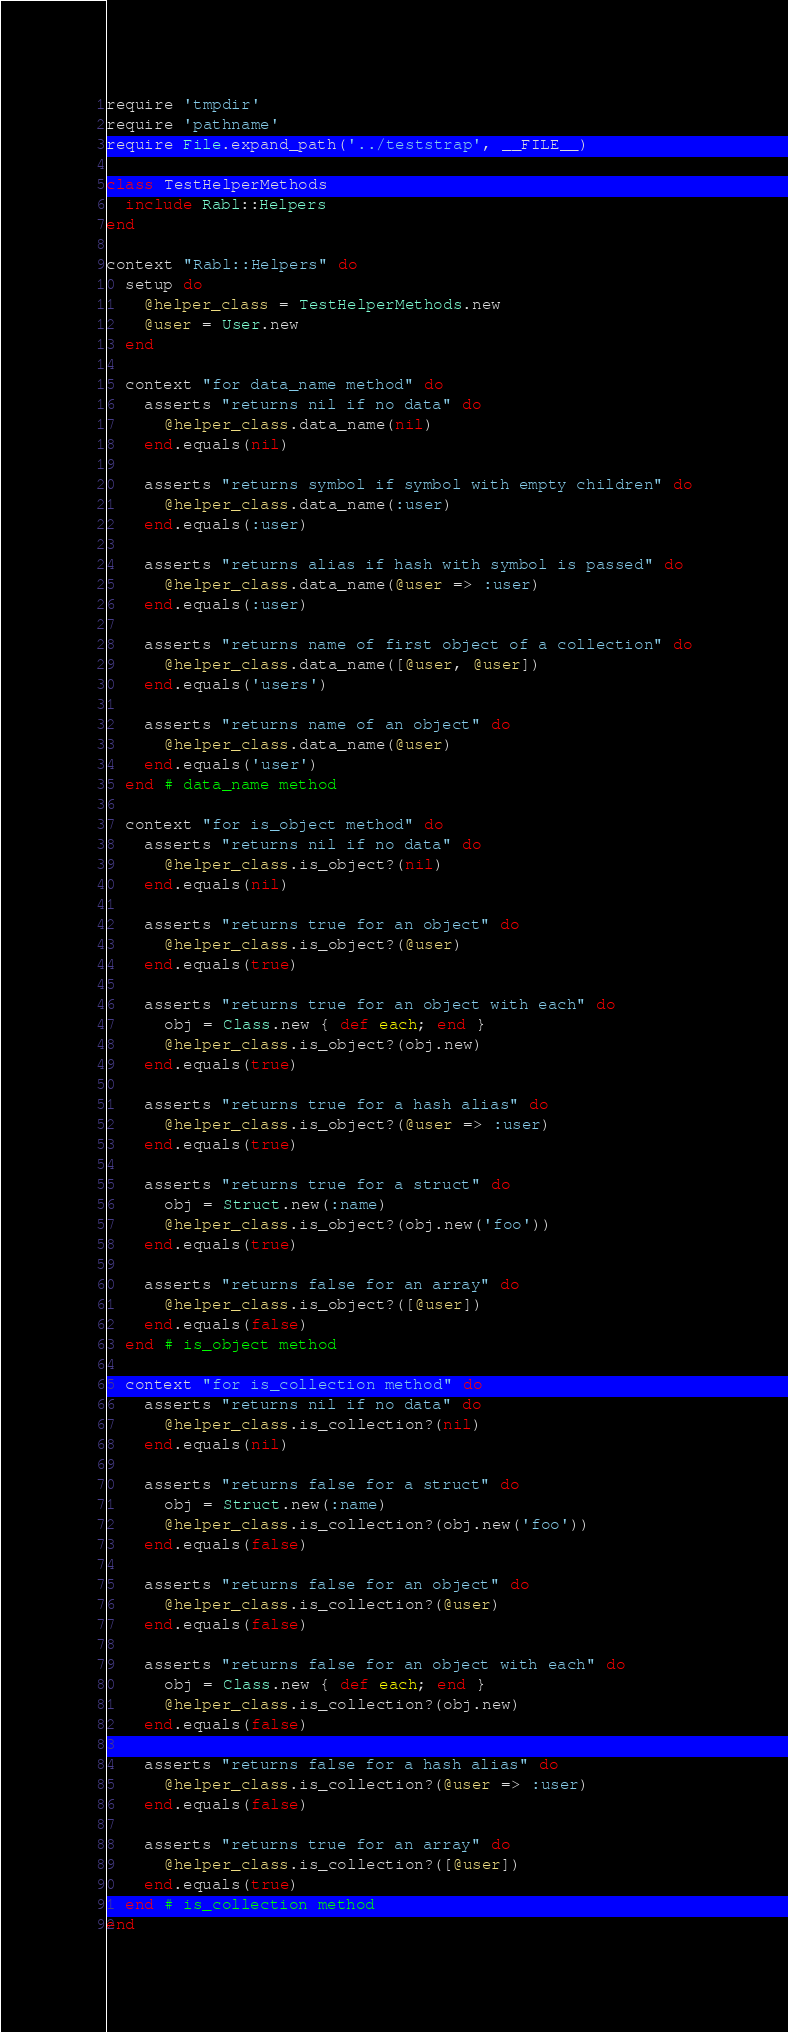<code> <loc_0><loc_0><loc_500><loc_500><_Ruby_>require 'tmpdir'
require 'pathname'
require File.expand_path('../teststrap', __FILE__)

class TestHelperMethods
  include Rabl::Helpers
end

context "Rabl::Helpers" do
  setup do
    @helper_class = TestHelperMethods.new
    @user = User.new
  end

  context "for data_name method" do
    asserts "returns nil if no data" do
      @helper_class.data_name(nil)
    end.equals(nil)

    asserts "returns symbol if symbol with empty children" do
      @helper_class.data_name(:user)
    end.equals(:user)

    asserts "returns alias if hash with symbol is passed" do
      @helper_class.data_name(@user => :user)
    end.equals(:user)

    asserts "returns name of first object of a collection" do
      @helper_class.data_name([@user, @user])
    end.equals('users')

    asserts "returns name of an object" do
      @helper_class.data_name(@user)
    end.equals('user')
  end # data_name method

  context "for is_object method" do
    asserts "returns nil if no data" do
      @helper_class.is_object?(nil)
    end.equals(nil)

    asserts "returns true for an object" do
      @helper_class.is_object?(@user)
    end.equals(true)

    asserts "returns true for an object with each" do
      obj = Class.new { def each; end }
      @helper_class.is_object?(obj.new)
    end.equals(true)

    asserts "returns true for a hash alias" do
      @helper_class.is_object?(@user => :user)
    end.equals(true)

    asserts "returns true for a struct" do
      obj = Struct.new(:name)
      @helper_class.is_object?(obj.new('foo'))
    end.equals(true)

    asserts "returns false for an array" do
      @helper_class.is_object?([@user])
    end.equals(false)
  end # is_object method

  context "for is_collection method" do
    asserts "returns nil if no data" do
      @helper_class.is_collection?(nil)
    end.equals(nil)

    asserts "returns false for a struct" do
      obj = Struct.new(:name)
      @helper_class.is_collection?(obj.new('foo'))
    end.equals(false)

    asserts "returns false for an object" do
      @helper_class.is_collection?(@user)
    end.equals(false)

    asserts "returns false for an object with each" do
      obj = Class.new { def each; end }
      @helper_class.is_collection?(obj.new)
    end.equals(false)

    asserts "returns false for a hash alias" do
      @helper_class.is_collection?(@user => :user)
    end.equals(false)

    asserts "returns true for an array" do
      @helper_class.is_collection?([@user])
    end.equals(true)
  end # is_collection method
end
</code> 